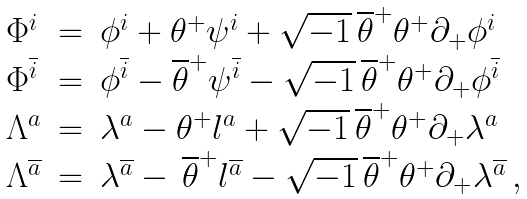Convert formula to latex. <formula><loc_0><loc_0><loc_500><loc_500>\begin{array} { l l l } { { \Phi ^ { i } } } & { = } & { { \phi ^ { i } + \theta ^ { + } \psi ^ { i } + \sqrt { - 1 } \, \overline { \theta } ^ { + } \theta ^ { + } \partial _ { + } \phi ^ { i } } } \\ { { \Phi ^ { \overline { i } } } } & { = } & { { \phi ^ { \overline { i } } - \overline { \theta } ^ { + } \psi ^ { \overline { i } } - \sqrt { - 1 } \, \overline { \theta } ^ { + } \theta ^ { + } \partial _ { + } \phi ^ { \overline { i } } } } \\ { { \Lambda ^ { a } } } & { = } & { { \lambda ^ { a } - \theta ^ { + } l ^ { a } + \sqrt { - 1 } \, \overline { \theta } ^ { + } \theta ^ { + } \partial _ { + } \lambda ^ { a } } } \\ { { \Lambda ^ { \overline { a } } } } & { = } & { { \lambda ^ { \overline { a } } - \, \overline { \theta } ^ { + } l ^ { \overline { a } } - \sqrt { - 1 } \, \overline { \theta } ^ { + } \theta ^ { + } \partial _ { + } \lambda ^ { \overline { a } } \, , } } \end{array}</formula> 